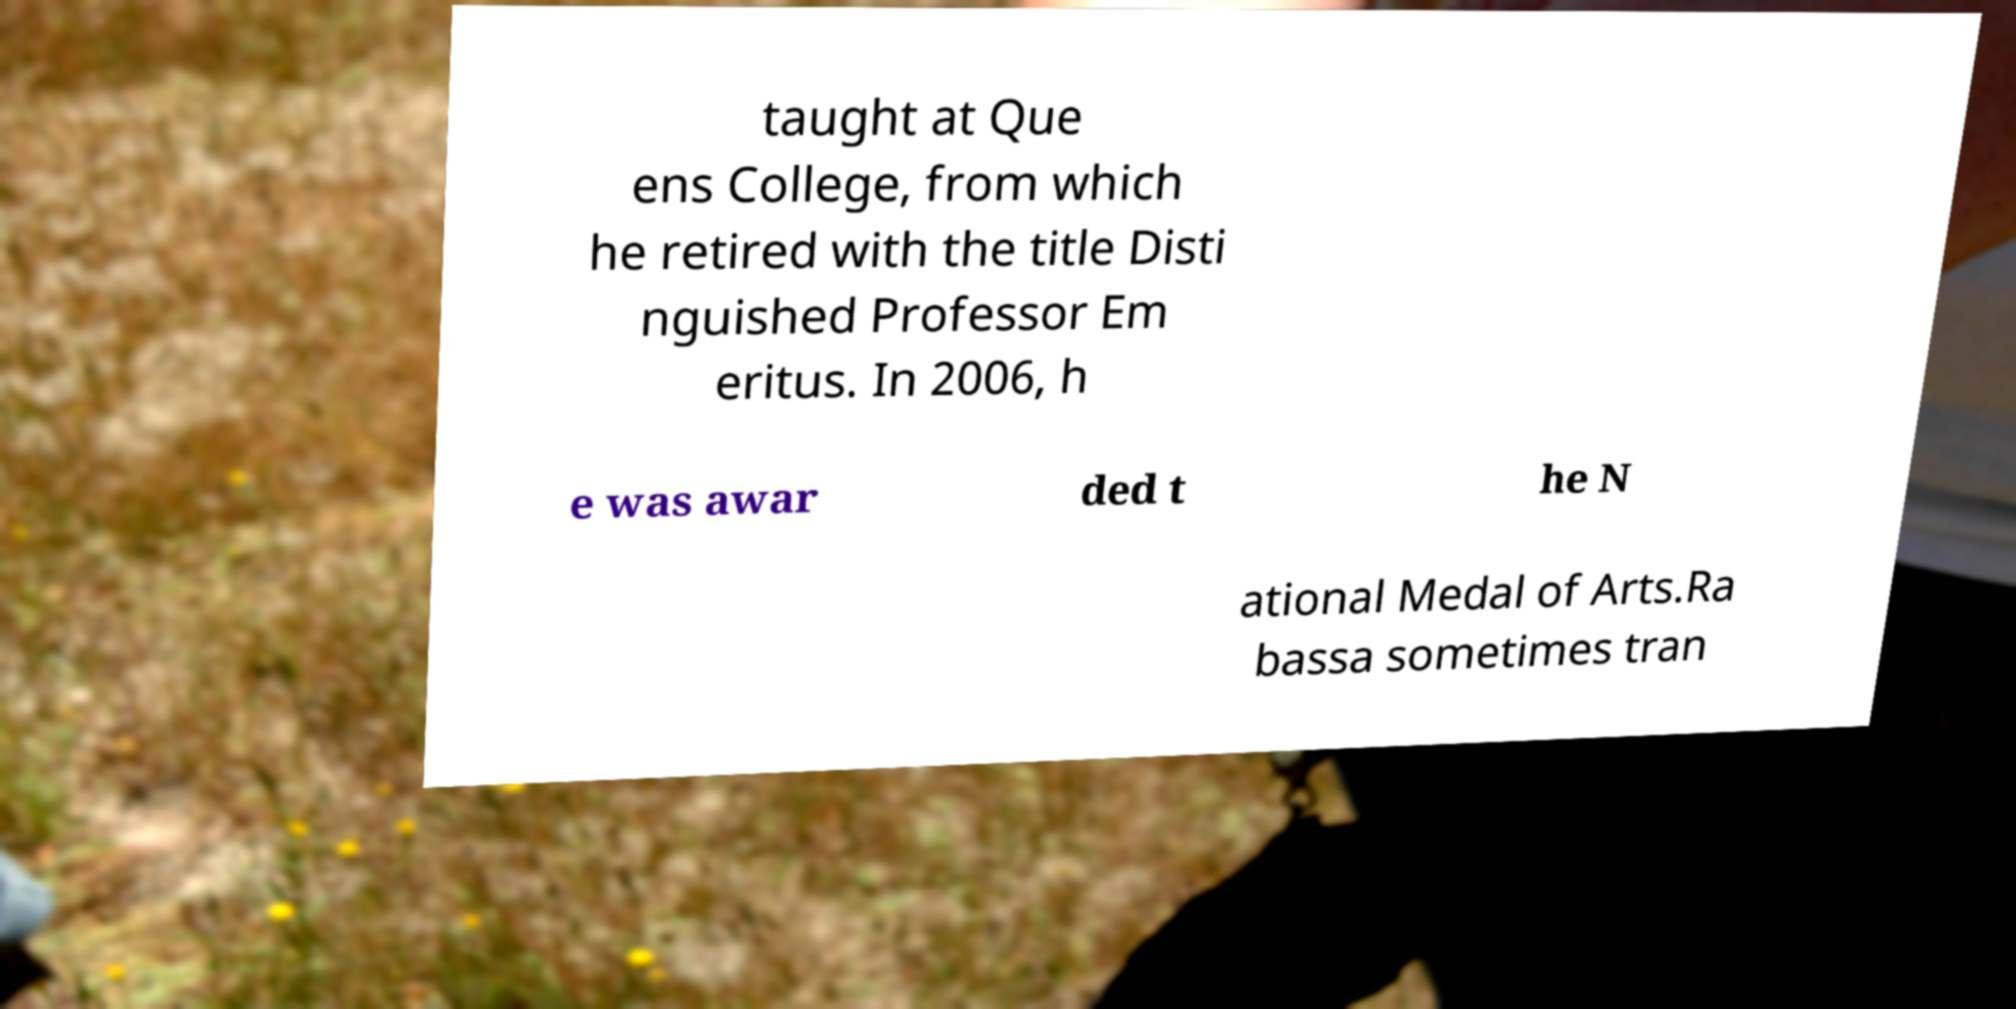Could you extract and type out the text from this image? taught at Que ens College, from which he retired with the title Disti nguished Professor Em eritus. In 2006, h e was awar ded t he N ational Medal of Arts.Ra bassa sometimes tran 